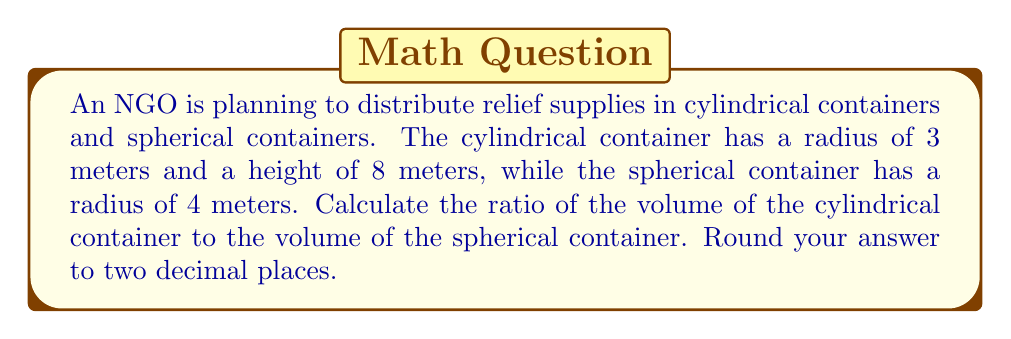Show me your answer to this math problem. Let's approach this step-by-step:

1. Calculate the volume of the cylindrical container:
   The formula for the volume of a cylinder is $V_c = \pi r^2 h$
   where $r$ is the radius and $h$ is the height.
   
   $$V_c = \pi (3\text{ m})^2 (8\text{ m}) = 72\pi \text{ m}^3$$

2. Calculate the volume of the spherical container:
   The formula for the volume of a sphere is $V_s = \frac{4}{3}\pi r^3$
   where $r$ is the radius.
   
   $$V_s = \frac{4}{3}\pi (4\text{ m})^3 = \frac{256}{3}\pi \text{ m}^3$$

3. Calculate the ratio of the volumes:
   Ratio = $\frac{\text{Volume of cylinder}}{\text{Volume of sphere}} = \frac{V_c}{V_s}$
   
   $$\frac{V_c}{V_s} = \frac{72\pi \text{ m}^3}{\frac{256}{3}\pi \text{ m}^3} = \frac{72\pi}{\frac{256}{3}\pi} = \frac{72 \cdot 3}{256} = \frac{216}{256} = 0.84375$$

4. Round the result to two decimal places:
   0.84375 rounds to 0.84

This ratio indicates that the cylindrical container has approximately 84% of the volume of the spherical container.
Answer: 0.84 